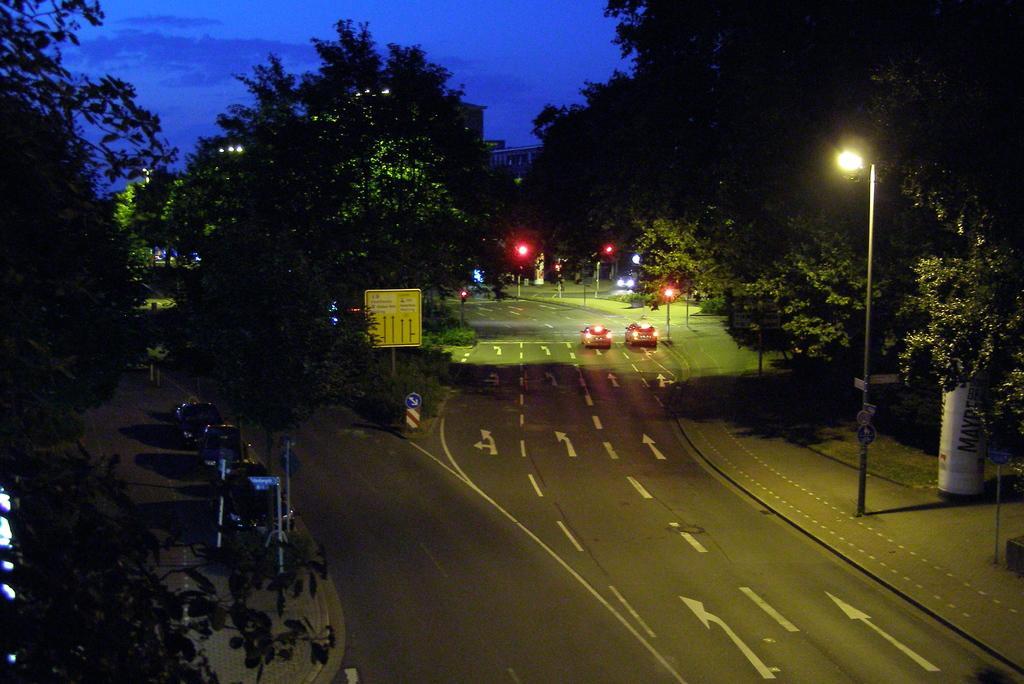Please provide a concise description of this image. In this image, there is an outside view. There are some trees beside the road. There are cars in the middle of the image. There is a sky at the top of the image. There is a pole on the right side of the image. 